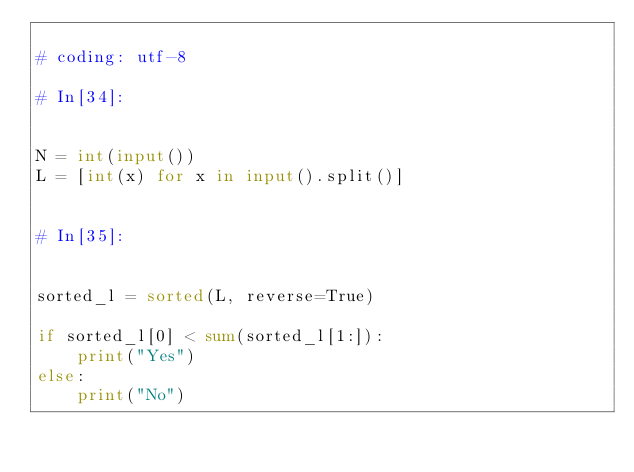<code> <loc_0><loc_0><loc_500><loc_500><_Python_>
# coding: utf-8

# In[34]:


N = int(input())
L = [int(x) for x in input().split()]


# In[35]:


sorted_l = sorted(L, reverse=True)

if sorted_l[0] < sum(sorted_l[1:]):
    print("Yes")
else:
    print("No")

</code> 